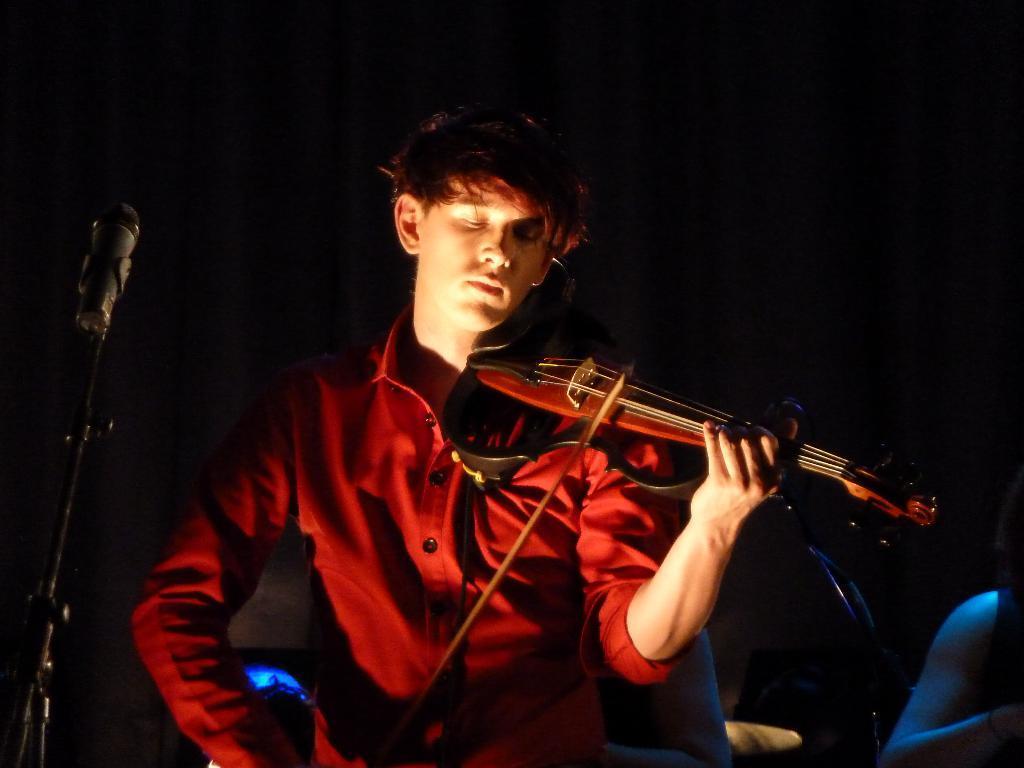Please provide a concise description of this image. In this image the man is playing a musical instrument. There is a mic and stand. At the back side there is a curtain. 